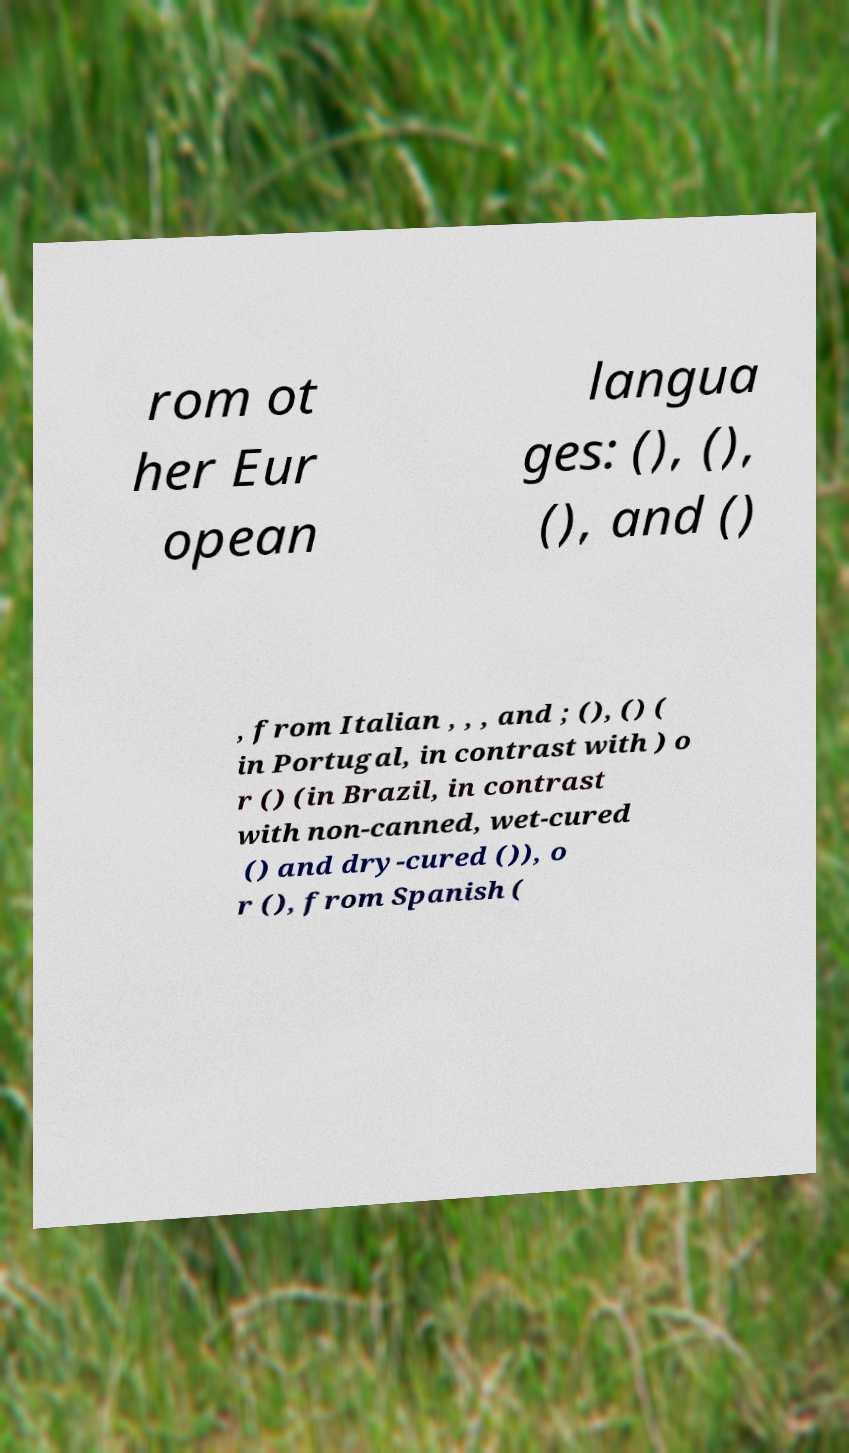There's text embedded in this image that I need extracted. Can you transcribe it verbatim? rom ot her Eur opean langua ges: (), (), (), and () , from Italian , , , and ; (), () ( in Portugal, in contrast with ) o r () (in Brazil, in contrast with non-canned, wet-cured () and dry-cured ()), o r (), from Spanish ( 